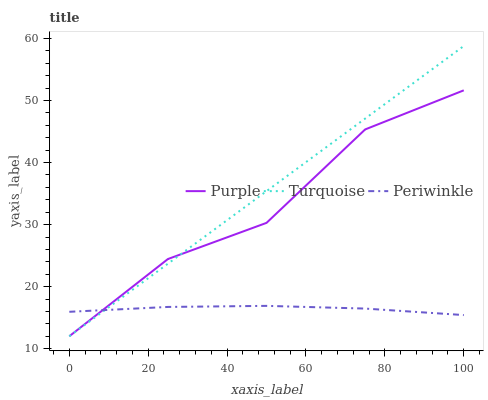Does Periwinkle have the minimum area under the curve?
Answer yes or no. Yes. Does Turquoise have the maximum area under the curve?
Answer yes or no. Yes. Does Turquoise have the minimum area under the curve?
Answer yes or no. No. Does Periwinkle have the maximum area under the curve?
Answer yes or no. No. Is Turquoise the smoothest?
Answer yes or no. Yes. Is Purple the roughest?
Answer yes or no. Yes. Is Periwinkle the smoothest?
Answer yes or no. No. Is Periwinkle the roughest?
Answer yes or no. No. Does Purple have the lowest value?
Answer yes or no. Yes. Does Periwinkle have the lowest value?
Answer yes or no. No. Does Turquoise have the highest value?
Answer yes or no. Yes. Does Periwinkle have the highest value?
Answer yes or no. No. Does Purple intersect Turquoise?
Answer yes or no. Yes. Is Purple less than Turquoise?
Answer yes or no. No. Is Purple greater than Turquoise?
Answer yes or no. No. 